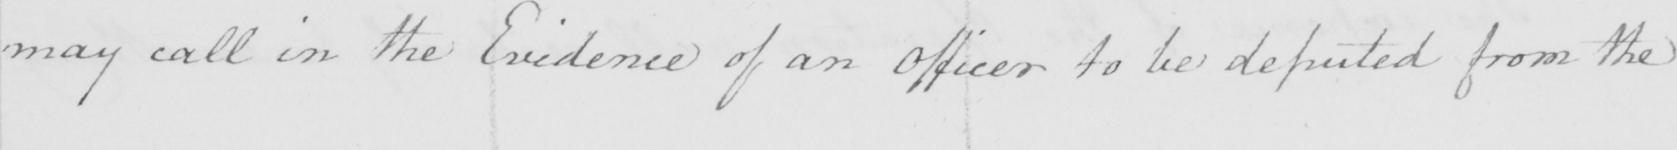Can you tell me what this handwritten text says? may call in the Evidence of an Officer to be deputed from the 